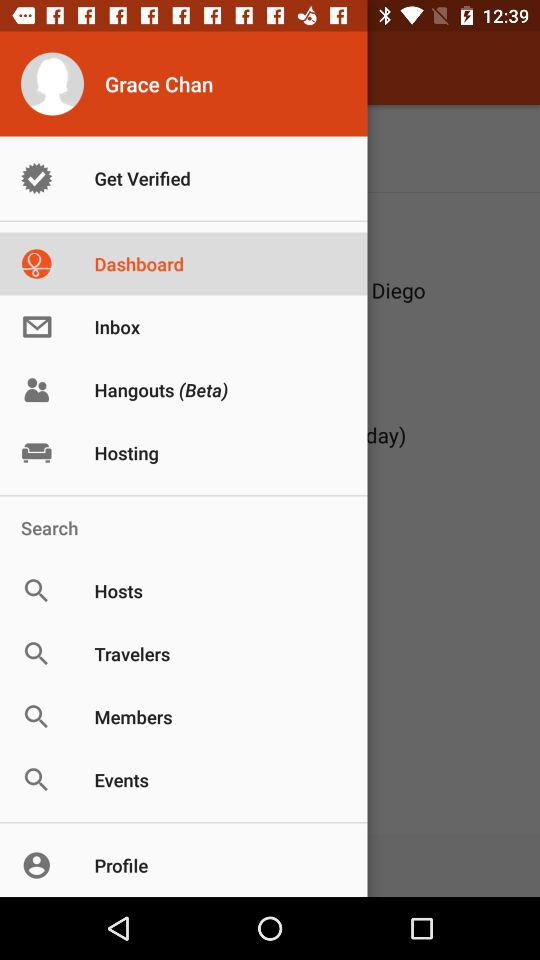Which item is selected? The selected item is "Dashboard". 